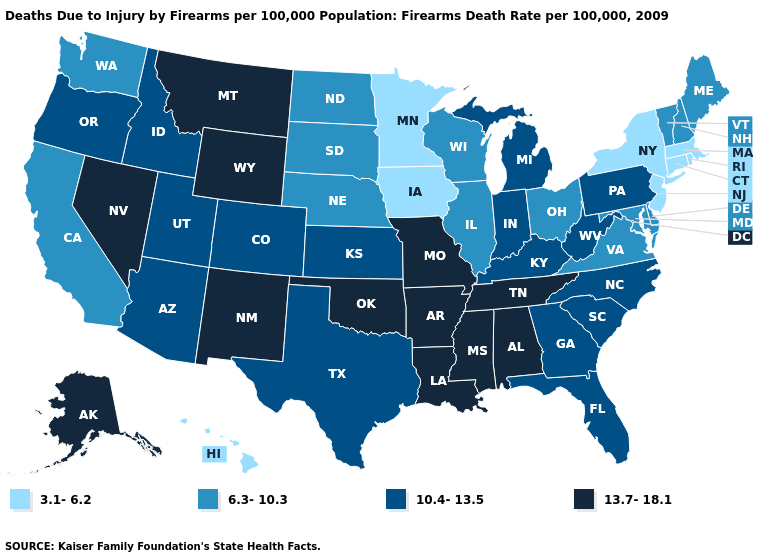How many symbols are there in the legend?
Give a very brief answer. 4. Is the legend a continuous bar?
Answer briefly. No. What is the value of Ohio?
Write a very short answer. 6.3-10.3. What is the value of Tennessee?
Write a very short answer. 13.7-18.1. Which states have the highest value in the USA?
Keep it brief. Alabama, Alaska, Arkansas, Louisiana, Mississippi, Missouri, Montana, Nevada, New Mexico, Oklahoma, Tennessee, Wyoming. Which states have the lowest value in the USA?
Short answer required. Connecticut, Hawaii, Iowa, Massachusetts, Minnesota, New Jersey, New York, Rhode Island. How many symbols are there in the legend?
Give a very brief answer. 4. Which states have the lowest value in the USA?
Answer briefly. Connecticut, Hawaii, Iowa, Massachusetts, Minnesota, New Jersey, New York, Rhode Island. What is the highest value in states that border Wisconsin?
Keep it brief. 10.4-13.5. What is the value of Utah?
Short answer required. 10.4-13.5. Among the states that border Wyoming , which have the lowest value?
Be succinct. Nebraska, South Dakota. Does the map have missing data?
Write a very short answer. No. What is the value of Nebraska?
Keep it brief. 6.3-10.3. What is the value of Kansas?
Short answer required. 10.4-13.5. What is the value of West Virginia?
Be succinct. 10.4-13.5. 